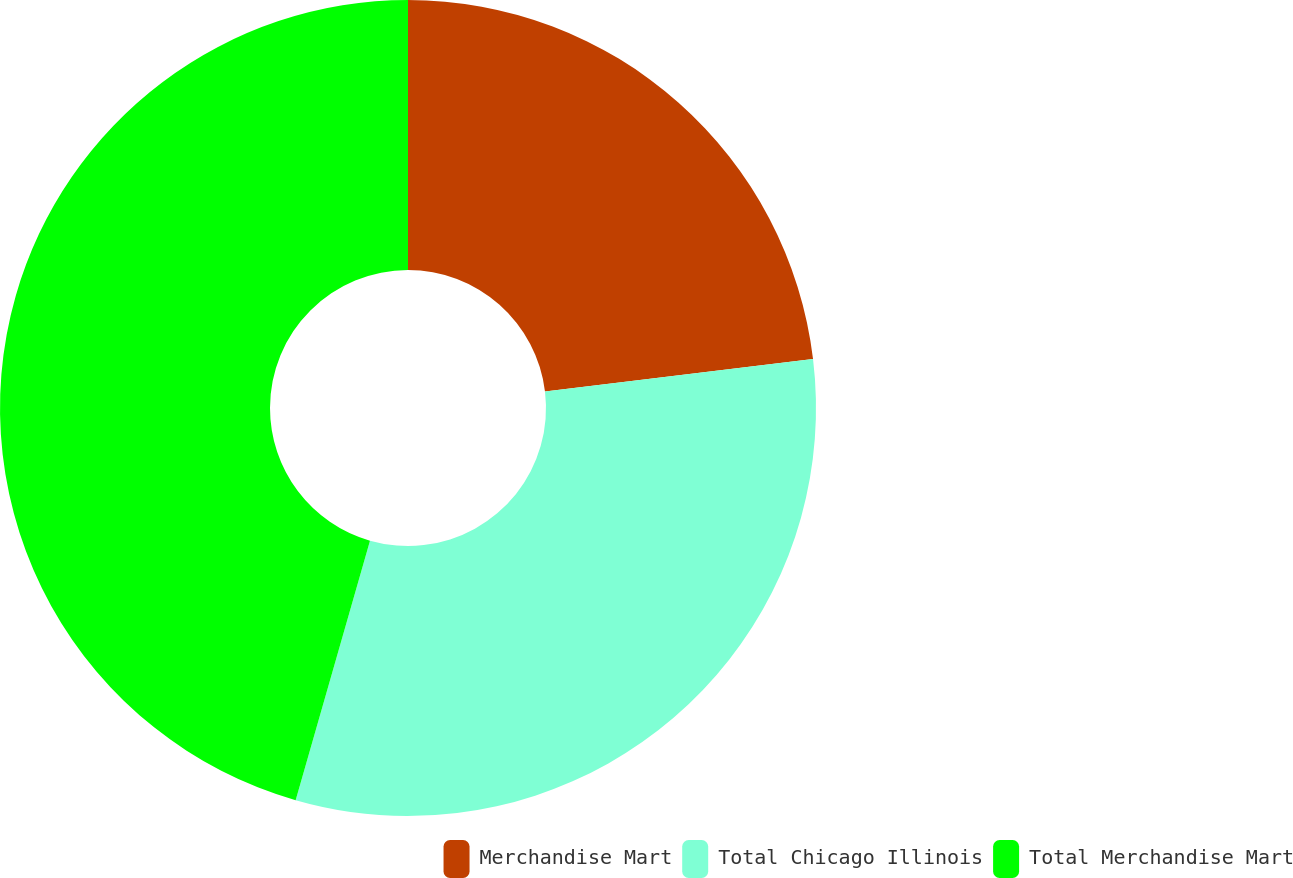<chart> <loc_0><loc_0><loc_500><loc_500><pie_chart><fcel>Merchandise Mart<fcel>Total Chicago Illinois<fcel>Total Merchandise Mart<nl><fcel>23.08%<fcel>31.36%<fcel>45.56%<nl></chart> 